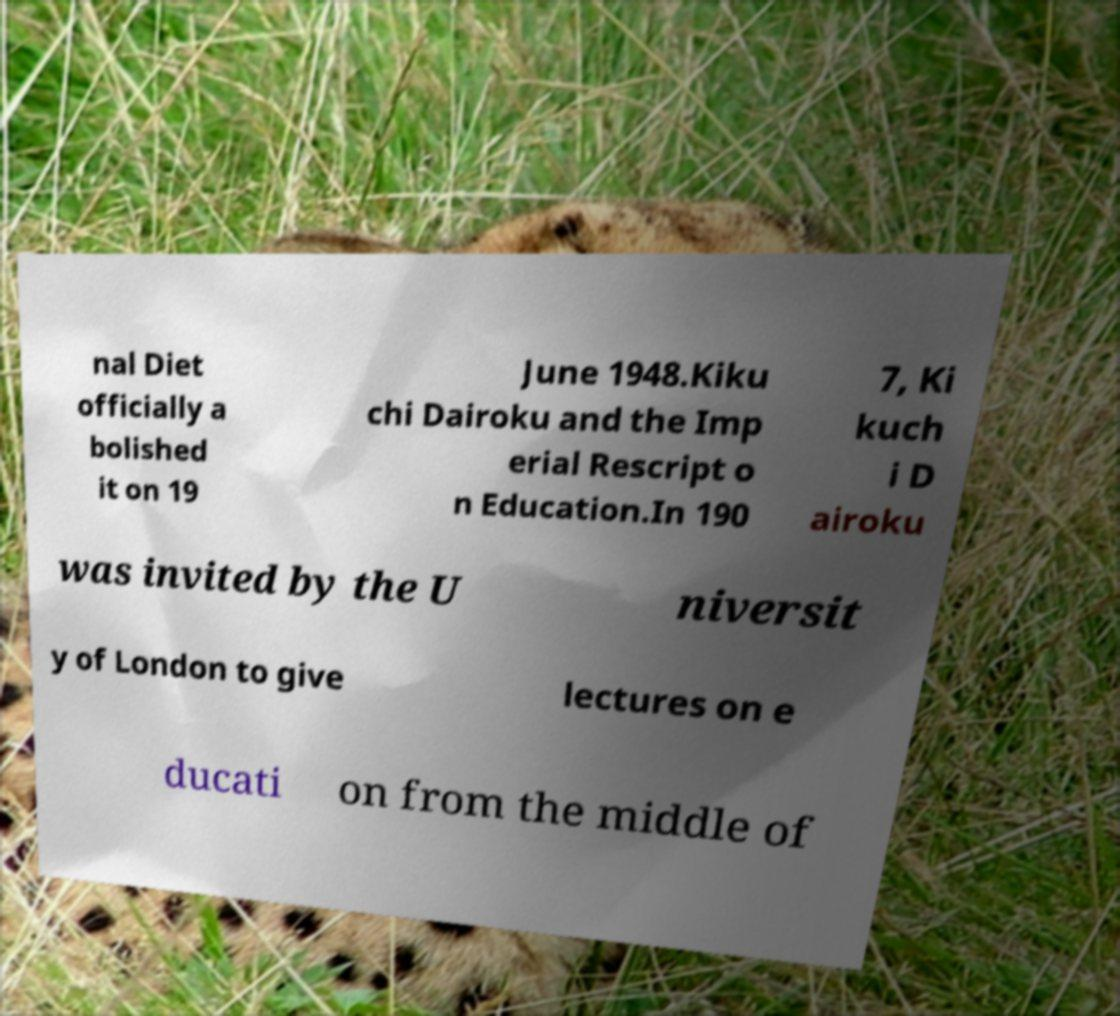Can you read and provide the text displayed in the image?This photo seems to have some interesting text. Can you extract and type it out for me? nal Diet officially a bolished it on 19 June 1948.Kiku chi Dairoku and the Imp erial Rescript o n Education.In 190 7, Ki kuch i D airoku was invited by the U niversit y of London to give lectures on e ducati on from the middle of 